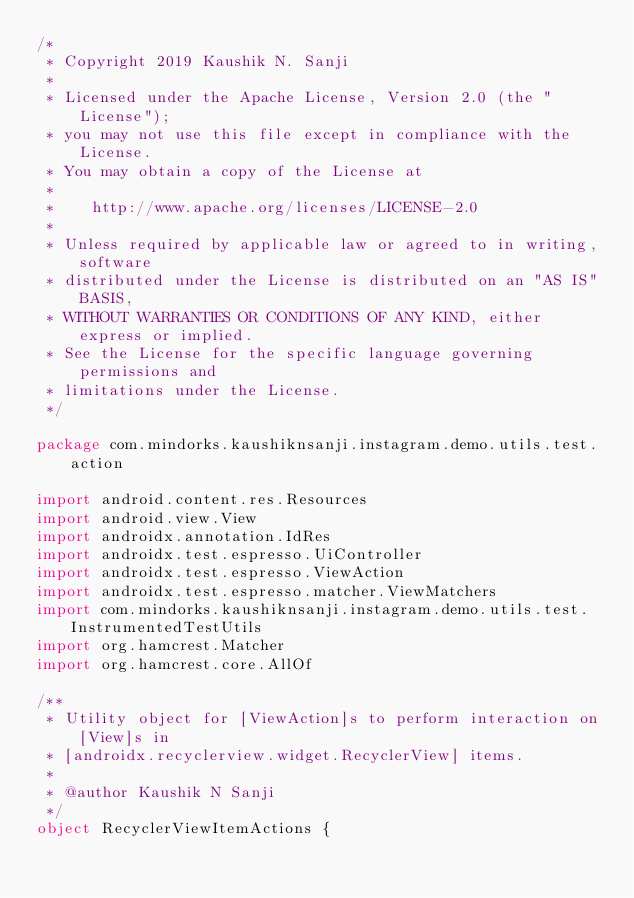<code> <loc_0><loc_0><loc_500><loc_500><_Kotlin_>/*
 * Copyright 2019 Kaushik N. Sanji
 *
 * Licensed under the Apache License, Version 2.0 (the "License");
 * you may not use this file except in compliance with the License.
 * You may obtain a copy of the License at
 *
 *    http://www.apache.org/licenses/LICENSE-2.0
 *
 * Unless required by applicable law or agreed to in writing, software
 * distributed under the License is distributed on an "AS IS" BASIS,
 * WITHOUT WARRANTIES OR CONDITIONS OF ANY KIND, either express or implied.
 * See the License for the specific language governing permissions and
 * limitations under the License.
 */

package com.mindorks.kaushiknsanji.instagram.demo.utils.test.action

import android.content.res.Resources
import android.view.View
import androidx.annotation.IdRes
import androidx.test.espresso.UiController
import androidx.test.espresso.ViewAction
import androidx.test.espresso.matcher.ViewMatchers
import com.mindorks.kaushiknsanji.instagram.demo.utils.test.InstrumentedTestUtils
import org.hamcrest.Matcher
import org.hamcrest.core.AllOf

/**
 * Utility object for [ViewAction]s to perform interaction on [View]s in
 * [androidx.recyclerview.widget.RecyclerView] items.
 *
 * @author Kaushik N Sanji
 */
object RecyclerViewItemActions {
</code> 